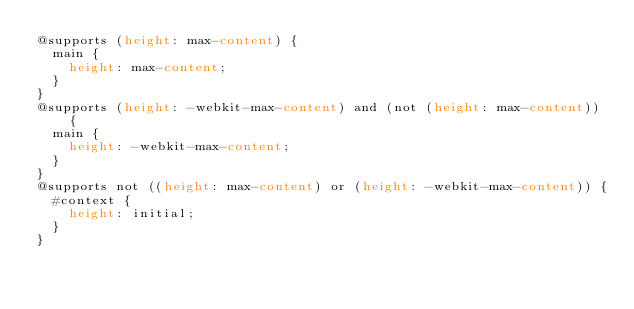Convert code to text. <code><loc_0><loc_0><loc_500><loc_500><_CSS_>@supports (height: max-content) {
  main {
    height: max-content;
  }
}
@supports (height: -webkit-max-content) and (not (height: max-content)) {
  main {
    height: -webkit-max-content;
  }
}
@supports not ((height: max-content) or (height: -webkit-max-content)) {
  #context {
    height: initial;
  }
}</code> 